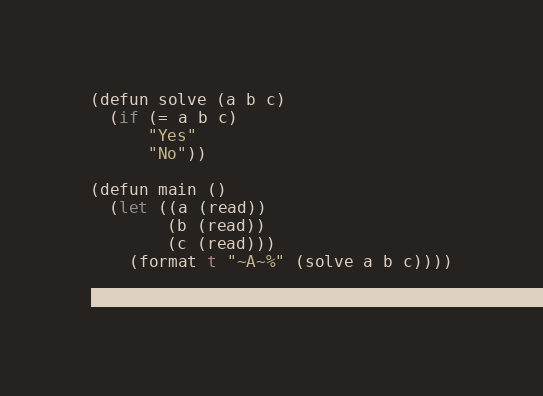<code> <loc_0><loc_0><loc_500><loc_500><_Lisp_>(defun solve (a b c)
  (if (= a b c)
      "Yes"
      "No"))

(defun main ()
  (let ((a (read))
        (b (read))
        (c (read)))
    (format t "~A~%" (solve a b c))))

(main)
</code> 